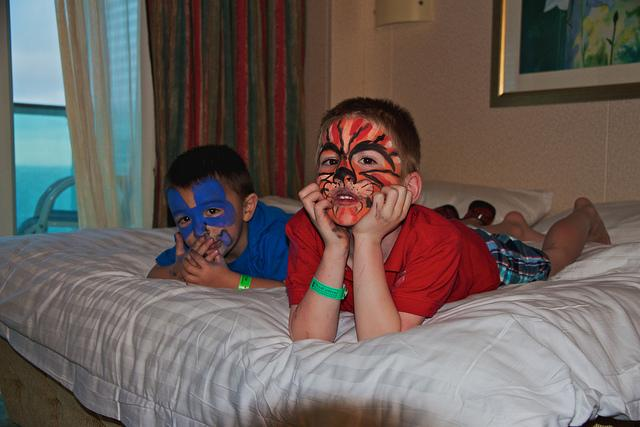Where are these children located? bed 